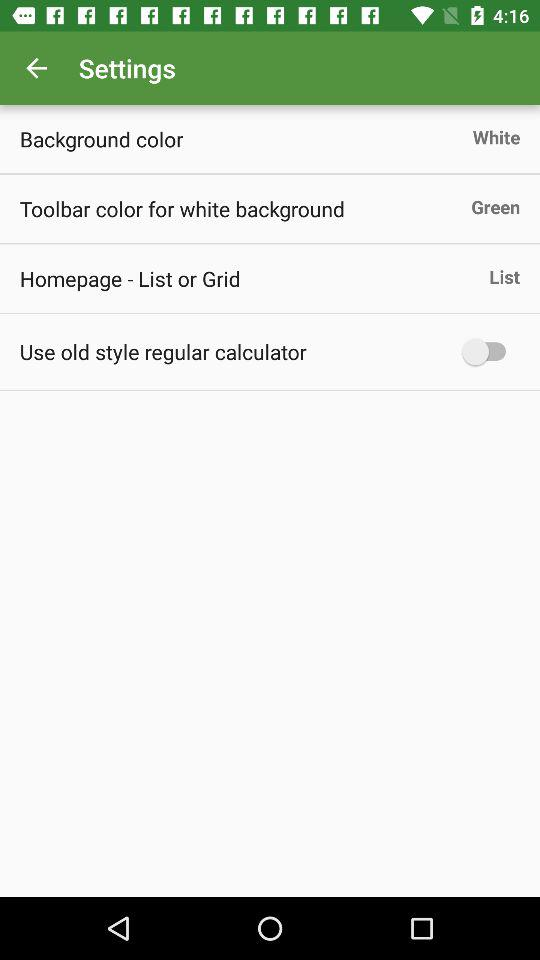What is the background color? The background color is white. 